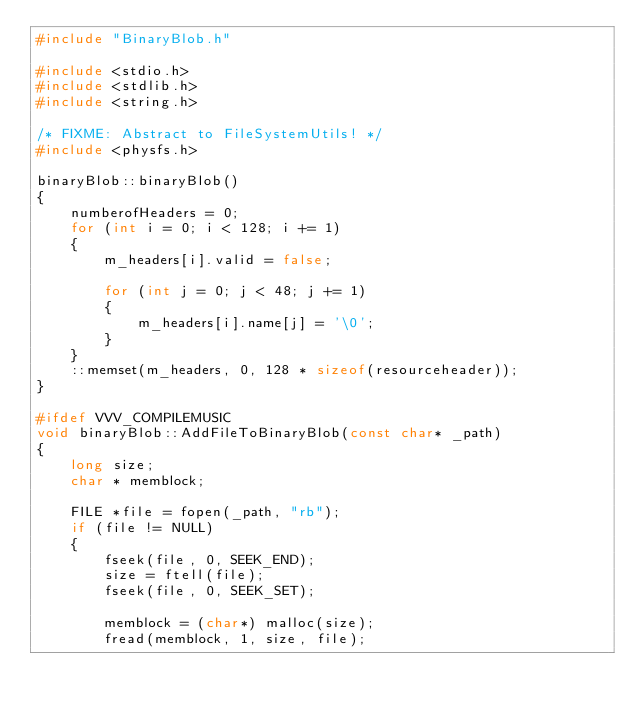<code> <loc_0><loc_0><loc_500><loc_500><_C++_>#include "BinaryBlob.h"

#include <stdio.h>
#include <stdlib.h>
#include <string.h>

/* FIXME: Abstract to FileSystemUtils! */
#include <physfs.h>

binaryBlob::binaryBlob()
{
	numberofHeaders = 0;
	for (int i = 0; i < 128; i += 1)
	{
		m_headers[i].valid = false;

		for (int j = 0; j < 48; j += 1)
		{
			m_headers[i].name[j] = '\0';
		}
	}
	::memset(m_headers, 0, 128 * sizeof(resourceheader));
}

#ifdef VVV_COMPILEMUSIC
void binaryBlob::AddFileToBinaryBlob(const char* _path)
{
	long size;
	char * memblock;

	FILE *file = fopen(_path, "rb");
	if (file != NULL)
	{
		fseek(file, 0, SEEK_END);
		size = ftell(file);
		fseek(file, 0, SEEK_SET);

		memblock = (char*) malloc(size);
		fread(memblock, 1, size, file);
</code> 